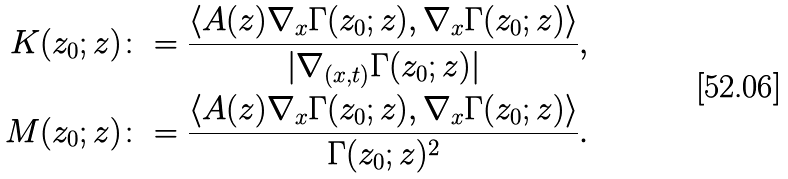Convert formula to latex. <formula><loc_0><loc_0><loc_500><loc_500>K ( z _ { 0 } ; z ) & \colon = \frac { \langle A ( z ) \nabla _ { x } \Gamma ( z _ { 0 } ; z ) , \nabla _ { x } \Gamma ( z _ { 0 } ; z ) \rangle } { | \nabla _ { ( x , t ) } \Gamma ( z _ { 0 } ; z ) | } , \\ M ( z _ { 0 } ; z ) & \colon = \frac { \langle A ( z ) \nabla _ { x } \Gamma ( z _ { 0 } ; z ) , \nabla _ { x } \Gamma ( z _ { 0 } ; z ) \rangle } { \Gamma ( z _ { 0 } ; z ) ^ { 2 } } .</formula> 